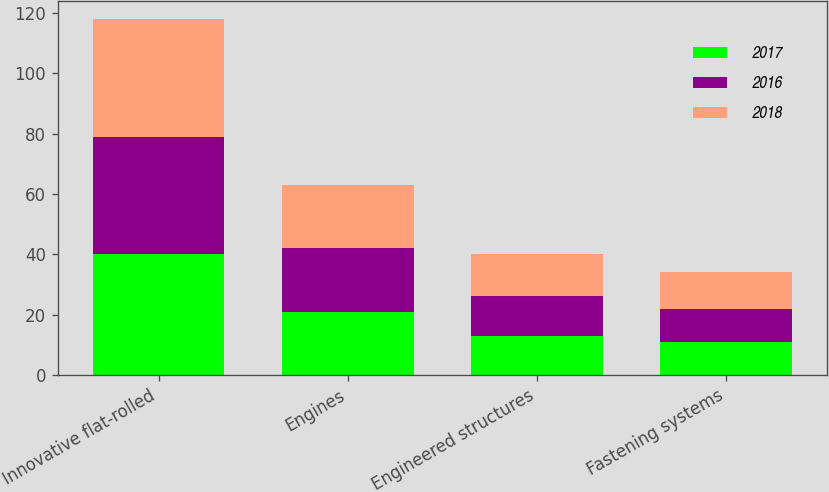<chart> <loc_0><loc_0><loc_500><loc_500><stacked_bar_chart><ecel><fcel>Innovative flat-rolled<fcel>Engines<fcel>Engineered structures<fcel>Fastening systems<nl><fcel>2017<fcel>40<fcel>21<fcel>13<fcel>11<nl><fcel>2016<fcel>39<fcel>21<fcel>13<fcel>11<nl><fcel>2018<fcel>39<fcel>21<fcel>14<fcel>12<nl></chart> 